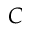Convert formula to latex. <formula><loc_0><loc_0><loc_500><loc_500>C</formula> 